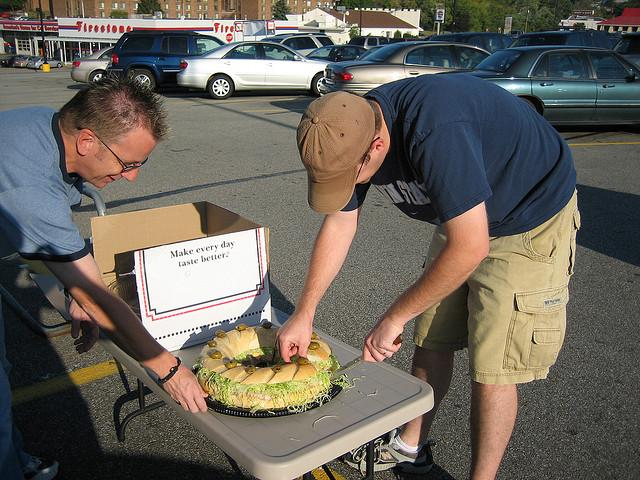How many days ago was this cake made? Please explain your reasoning. today. Food doesn't stay fresh and looking good for days. 